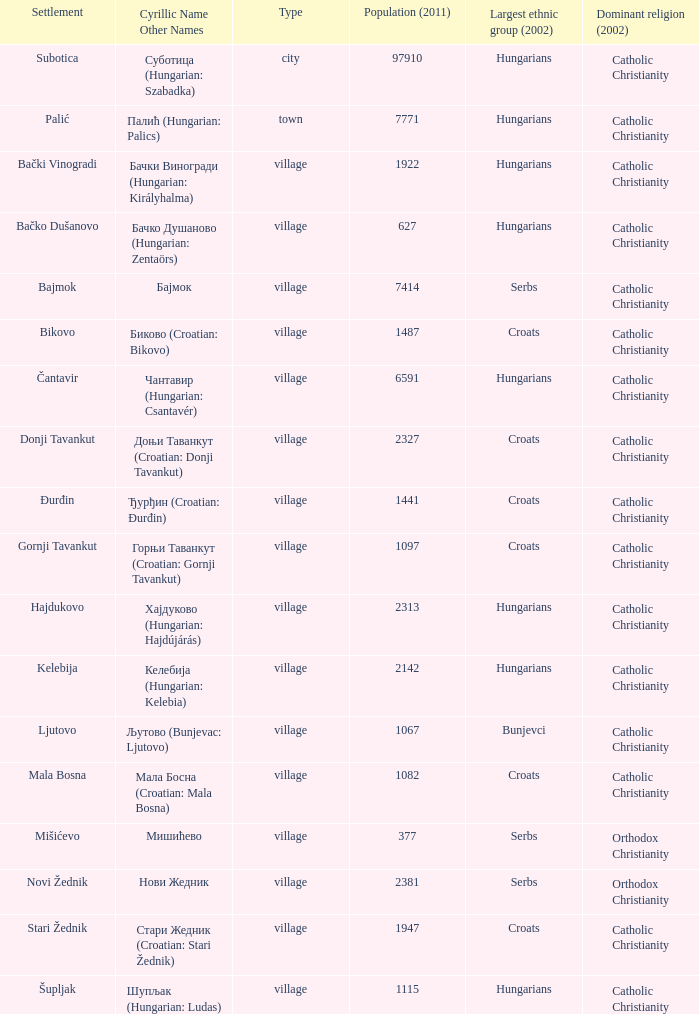Could you help me parse every detail presented in this table? {'header': ['Settlement', 'Cyrillic Name Other Names', 'Type', 'Population (2011)', 'Largest ethnic group (2002)', 'Dominant religion (2002)'], 'rows': [['Subotica', 'Суботица (Hungarian: Szabadka)', 'city', '97910', 'Hungarians', 'Catholic Christianity'], ['Palić', 'Палић (Hungarian: Palics)', 'town', '7771', 'Hungarians', 'Catholic Christianity'], ['Bački Vinogradi', 'Бачки Виногради (Hungarian: Királyhalma)', 'village', '1922', 'Hungarians', 'Catholic Christianity'], ['Bačko Dušanovo', 'Бачко Душаново (Hungarian: Zentaörs)', 'village', '627', 'Hungarians', 'Catholic Christianity'], ['Bajmok', 'Бајмок', 'village', '7414', 'Serbs', 'Catholic Christianity'], ['Bikovo', 'Биково (Croatian: Bikovo)', 'village', '1487', 'Croats', 'Catholic Christianity'], ['Čantavir', 'Чантавир (Hungarian: Csantavér)', 'village', '6591', 'Hungarians', 'Catholic Christianity'], ['Donji Tavankut', 'Доњи Таванкут (Croatian: Donji Tavankut)', 'village', '2327', 'Croats', 'Catholic Christianity'], ['Đurđin', 'Ђурђин (Croatian: Đurđin)', 'village', '1441', 'Croats', 'Catholic Christianity'], ['Gornji Tavankut', 'Горњи Таванкут (Croatian: Gornji Tavankut)', 'village', '1097', 'Croats', 'Catholic Christianity'], ['Hajdukovo', 'Хајдуково (Hungarian: Hajdújárás)', 'village', '2313', 'Hungarians', 'Catholic Christianity'], ['Kelebija', 'Келебија (Hungarian: Kelebia)', 'village', '2142', 'Hungarians', 'Catholic Christianity'], ['Ljutovo', 'Љутово (Bunjevac: Ljutovo)', 'village', '1067', 'Bunjevci', 'Catholic Christianity'], ['Mala Bosna', 'Мала Босна (Croatian: Mala Bosna)', 'village', '1082', 'Croats', 'Catholic Christianity'], ['Mišićevo', 'Мишићево', 'village', '377', 'Serbs', 'Orthodox Christianity'], ['Novi Žednik', 'Нови Жедник', 'village', '2381', 'Serbs', 'Orthodox Christianity'], ['Stari Žednik', 'Стари Жедник (Croatian: Stari Žednik)', 'village', '1947', 'Croats', 'Catholic Christianity'], ['Šupljak', 'Шупљак (Hungarian: Ludas)', 'village', '1115', 'Hungarians', 'Catholic Christianity']]} What is the population size in стари жедник (croatian: stari žедnik)? 1947.0. 